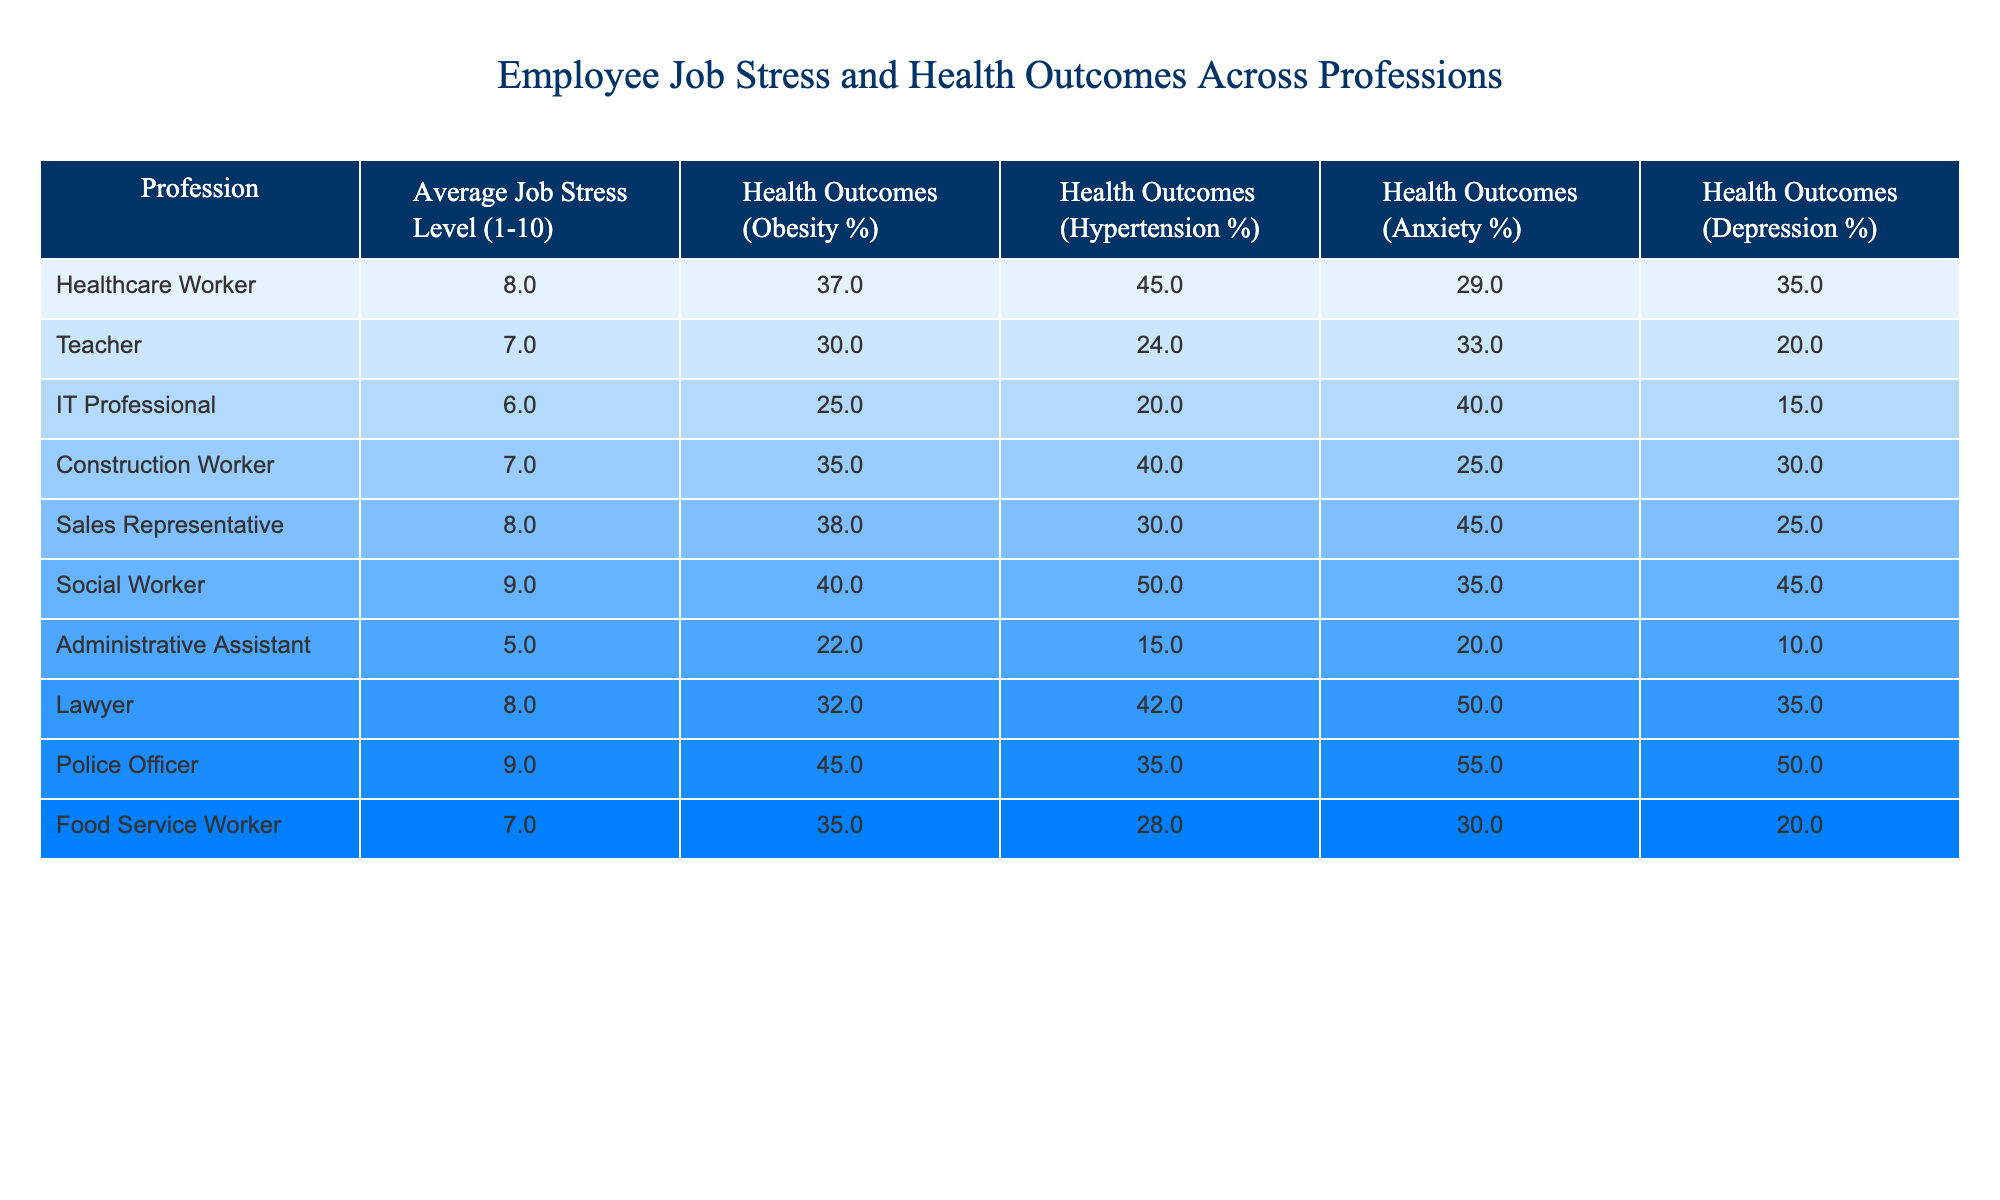What is the average job stress level for a Social Worker? Looking at the table, the average job stress level for a Social Worker is listed directly under the "Average Job Stress Level (1-10)" column for that profession. It shows a value of 9.
Answer: 9 Which profession has the highest percentage of obesity? By scanning through the "Health Outcomes (Obesity %)" column, we find that the profession with the highest percentage of obesity is the Police Officer, which is 45%.
Answer: 45% Is the average job stress level for Teachers higher than that of Administrative Assistants? Comparing the "Average Job Stress Level (1-10)" for both professions, Teachers have a level of 7, while Administrative Assistants have a level of 5. Since 7 is greater than 5, the statement is true.
Answer: Yes What is the total percentage of depression for Healthcare Workers and Police Officers combined? First, note the percentages for depression: Healthcare Workers have 35% and Police Officers have 50%. The total is found by adding these two values: 35 + 50 = 85%.
Answer: 85% Which profession has the lowest average job stress level, and what is that value? By reviewing the "Average Job Stress Level (1-10)" column, the lowest value is found for Administrative Assistants, which is 5.
Answer: 5 What percentage of teachers experience anxiety? To find the percentage of anxiety for teachers, refer to the "Health Outcomes (Anxiety %)" column corresponding to the Teacher row. The value there is 33%.
Answer: 33% Are IT Professionals more likely to suffer from depression than Food Service Workers? Checking the "Health Outcomes (Depression %)" column, IT Professionals have 15% and Food Service Workers have 20%. Since 15 is less than 20, IT Professionals are not more likely to suffer from depression.
Answer: No What is the average job stress level for professionals with obesity rates higher than 35%? The qualifying professions are Healthcare Workers (8), Sales Representatives (8), Social Workers (9), and Police Officers (9). The average is calculated as follows: (8 + 8 + 9 + 9) / 4 = 34 / 4 = 8.5.
Answer: 8.5 Which profession has a lower rate of hypertension, Healthcare Workers or Lawyers? By comparing the "Health Outcomes (Hypertension %)" for both, Healthcare Workers have 45% while Lawyers have 42%. Since 42% is lower than 45%, Lawyers have the lower rate.
Answer: Lawyers 